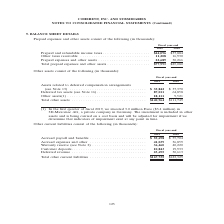According to Coherent's financial document, What was the Other taxes receivable in 2019? According to the financial document, 11,208 (in thousands). The relevant text states: "taxes . $44,096 $37,884 Other taxes receivable . 11,208 16,930 Prepaid expenses and other assets . 22,689 30,266..." Also, What was the  Prepaid expenses and other assets in 2018? According to the financial document, 30,266 (in thousands). The relevant text states: "16,930 Prepaid expenses and other assets . 22,689 30,266..." Also, In which year was Total prepaid expenses and other assets calculated? The document shows two values: 2019 and 2018. From the document: "Fiscal year-end 2019 2018 Fiscal year-end 2019 2018..." Additionally, In which year was Other taxes receivable larger? According to the financial document, 2018. The relevant text states: "Fiscal year-end 2019 2018..." Also, can you calculate: What was the change in Prepaid and refundable income taxes from 2018 to 2019? Based on the calculation: 44,096-37,884, the result is 6212 (in thousands). This is based on the information: "Prepaid and refundable income taxes . $44,096 $37,884 Other taxes receivable . 11,208 16,930 Prepaid expenses and other assets . 22,689 30,266 Prepaid and refundable income taxes . $44,096 $37,884 Oth..." The key data points involved are: 37,884, 44,096. Also, can you calculate: What was the percentage change in Prepaid and refundable income taxes from 2018 to 2019? To answer this question, I need to perform calculations using the financial data. The calculation is: (44,096-37,884)/37,884, which equals 16.4 (percentage). This is based on the information: "Prepaid and refundable income taxes . $44,096 $37,884 Other taxes receivable . 11,208 16,930 Prepaid expenses and other assets . 22,689 30,266 Prepaid and refundable income taxes . $44,096 $37,884 Oth..." The key data points involved are: 37,884, 44,096. 